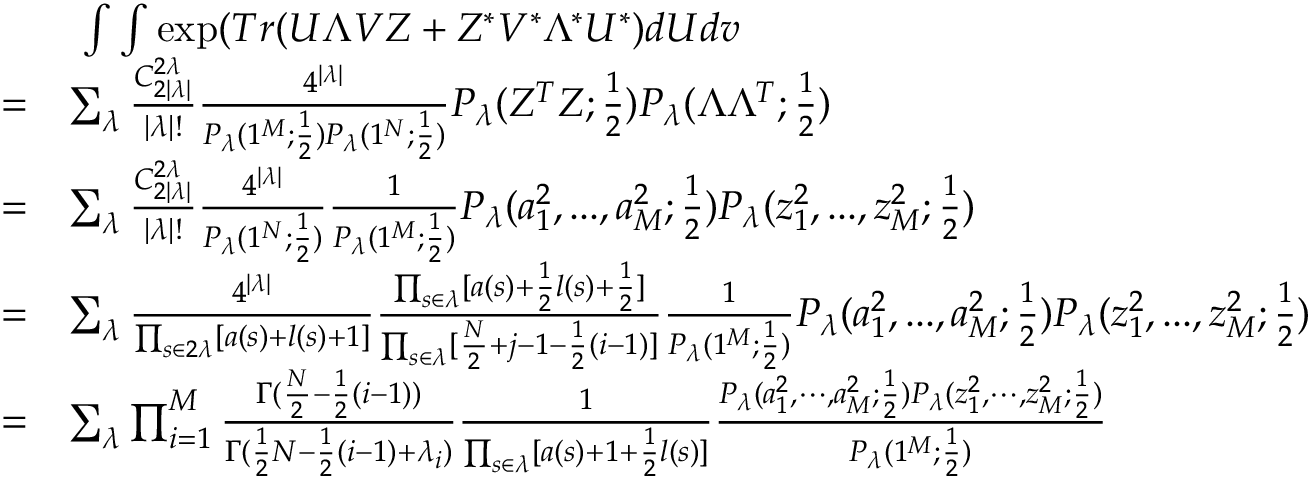<formula> <loc_0><loc_0><loc_500><loc_500>\begin{array} { r l } & { \ \int \int \exp ( T r ( U \Lambda V Z + Z ^ { * } V ^ { * } \Lambda ^ { * } U ^ { * } ) d U d v } \\ { = } & { \sum _ { \lambda } \frac { C _ { 2 | \lambda | } ^ { 2 \lambda } } { | \lambda | ! } \frac { 4 ^ { | \lambda | } } { P _ { \lambda } ( 1 ^ { M } ; \frac { 1 } { 2 } ) P _ { \lambda } ( 1 ^ { N } ; \frac { 1 } { 2 } ) } P _ { \lambda } ( Z ^ { T } Z ; \frac { 1 } { 2 } ) P _ { \lambda } ( \Lambda \Lambda ^ { T } ; \frac { 1 } { 2 } ) } \\ { = } & { \sum _ { \lambda } \frac { C _ { 2 | \lambda | } ^ { 2 \lambda } } { | \lambda | ! } \frac { 4 ^ { | \lambda | } } { P _ { \lambda } ( 1 ^ { N } ; \frac { 1 } { 2 } ) } \frac { 1 } { P _ { \lambda } ( 1 ^ { M } ; \frac { 1 } { 2 } ) } P _ { \lambda } ( a _ { 1 } ^ { 2 } , \dots , a _ { M } ^ { 2 } ; \frac { 1 } { 2 } ) P _ { \lambda } ( z _ { 1 } ^ { 2 } , \dots , z _ { M } ^ { 2 } ; \frac { 1 } { 2 } ) } \\ { = } & { \sum _ { \lambda } \frac { 4 ^ { | \lambda | } } { \prod _ { s \in 2 \lambda } [ a ( s ) + l ( s ) + 1 ] } \frac { \prod _ { s \in \lambda } [ a ( s ) + \frac { 1 } { 2 } l ( s ) + \frac { 1 } { 2 } ] } { \prod _ { s \in \lambda } [ \frac { N } { 2 } + j - 1 - \frac { 1 } { 2 } ( i - 1 ) ] } \frac { 1 } { P _ { \lambda } ( 1 ^ { M } ; \frac { 1 } { 2 } ) } P _ { \lambda } ( a _ { 1 } ^ { 2 } , \dots , a _ { M } ^ { 2 } ; \frac { 1 } { 2 } ) P _ { \lambda } ( z _ { 1 } ^ { 2 } , \dots , z _ { M } ^ { 2 } ; \frac { 1 } { 2 } ) } \\ { = } & { \sum _ { \lambda } \prod _ { i = 1 } ^ { M } \frac { \Gamma ( \frac { N } { 2 } - \frac { 1 } { 2 } ( i - 1 ) ) } { \Gamma ( \frac { 1 } { 2 } N - \frac { 1 } { 2 } ( i - 1 ) + \lambda _ { i } ) } \frac { 1 } { \prod _ { s \in \lambda } [ a ( s ) + 1 + \frac { 1 } { 2 } l ( s ) ] } \frac { P _ { \lambda } ( a _ { 1 } ^ { 2 } , \cdots , a _ { M } ^ { 2 } ; \frac { 1 } { 2 } ) P _ { \lambda } ( z _ { 1 } ^ { 2 } , \cdots , z _ { M } ^ { 2 } ; \frac { 1 } { 2 } ) } { P _ { \lambda } ( 1 ^ { M } ; \frac { 1 } { 2 } ) } } \end{array}</formula> 